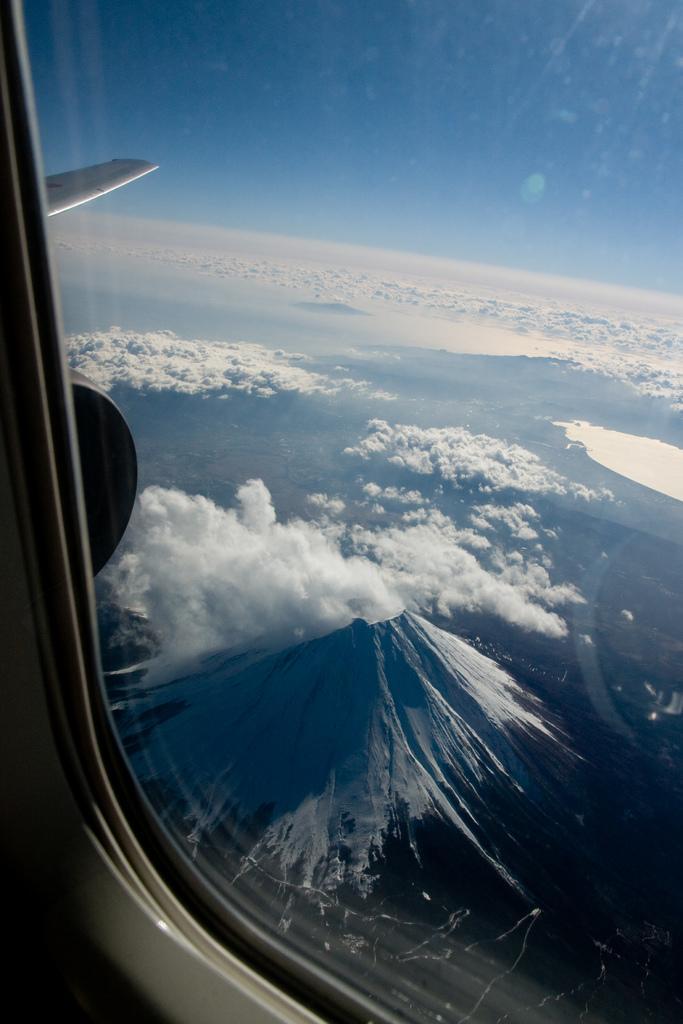Describe this image in one or two sentences. This picture is taken from inside of an airplane. Here I can see a window glass through which we can see the outside view. In the outside, I can see the clouds and sky. 